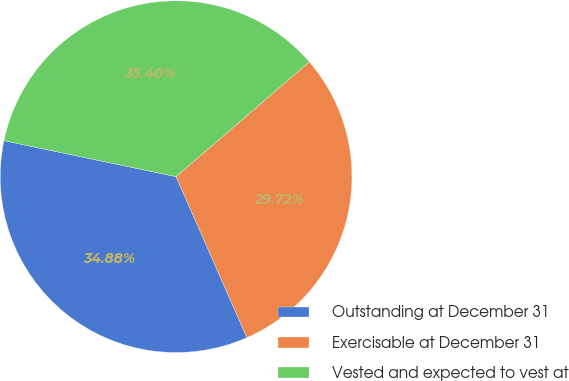Convert chart. <chart><loc_0><loc_0><loc_500><loc_500><pie_chart><fcel>Outstanding at December 31<fcel>Exercisable at December 31<fcel>Vested and expected to vest at<nl><fcel>34.88%<fcel>29.72%<fcel>35.4%<nl></chart> 